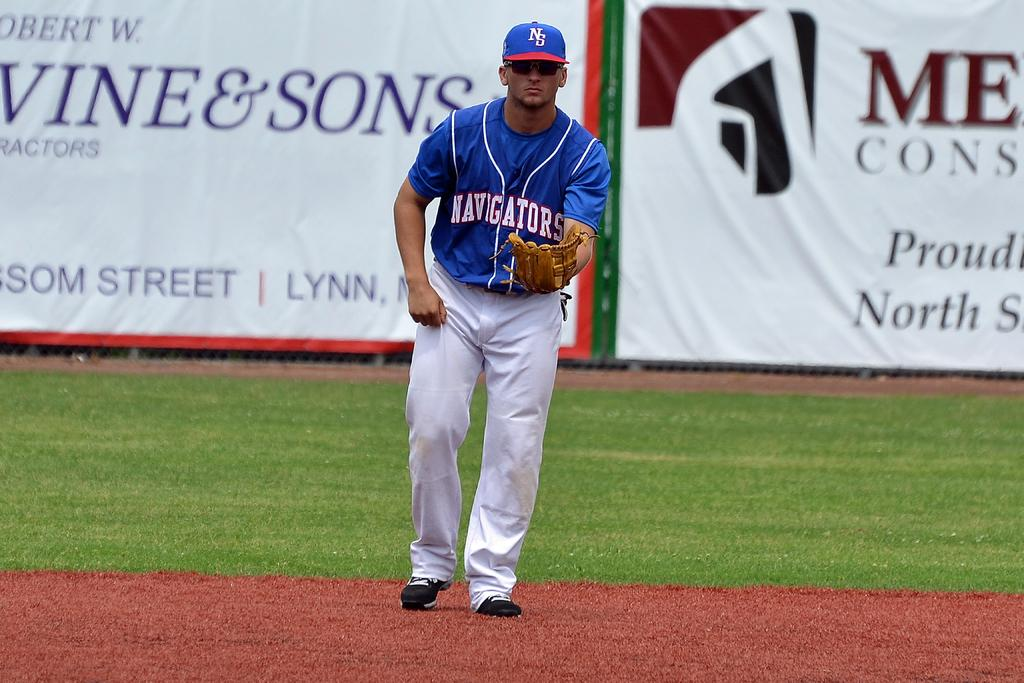Provide a one-sentence caption for the provided image. A player for the Navigators is on the baseball field. 